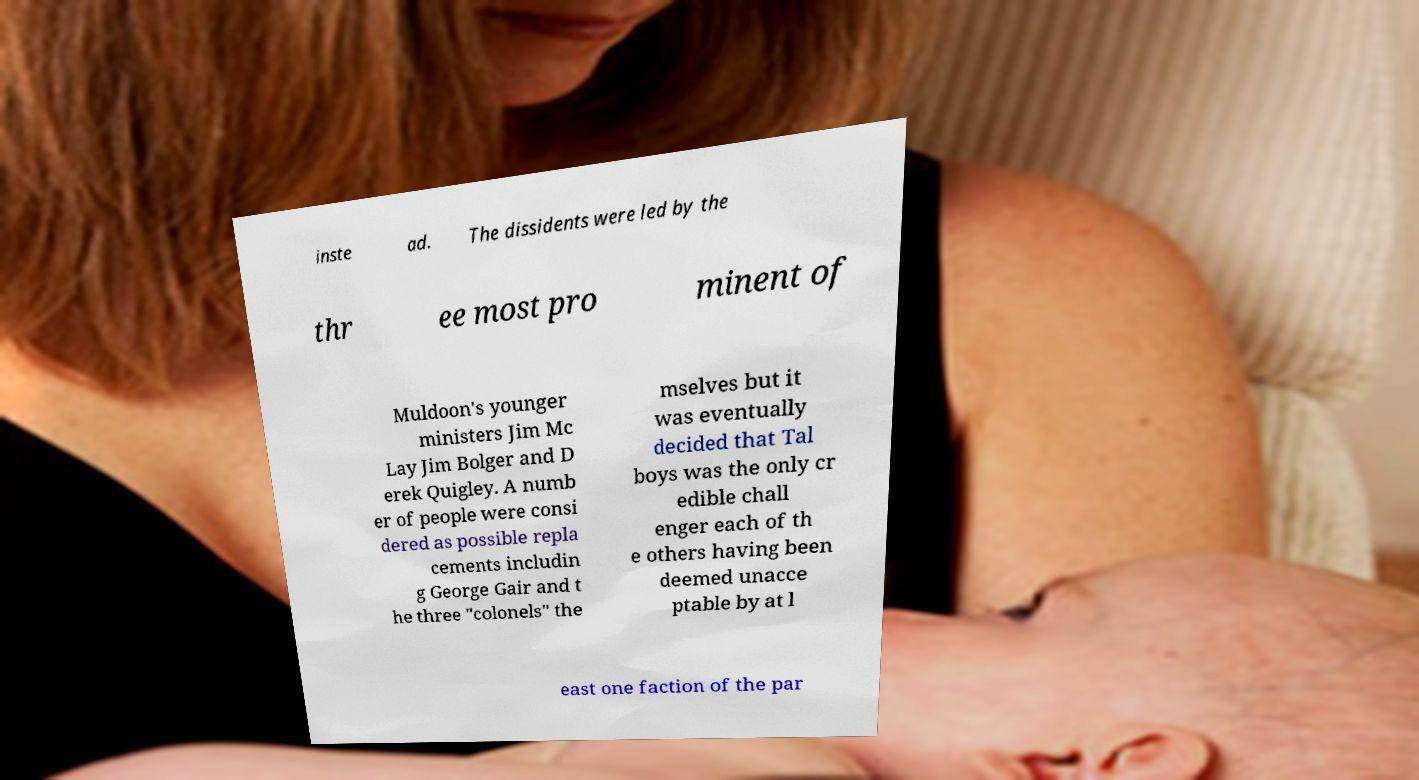Could you extract and type out the text from this image? inste ad. The dissidents were led by the thr ee most pro minent of Muldoon's younger ministers Jim Mc Lay Jim Bolger and D erek Quigley. A numb er of people were consi dered as possible repla cements includin g George Gair and t he three "colonels" the mselves but it was eventually decided that Tal boys was the only cr edible chall enger each of th e others having been deemed unacce ptable by at l east one faction of the par 